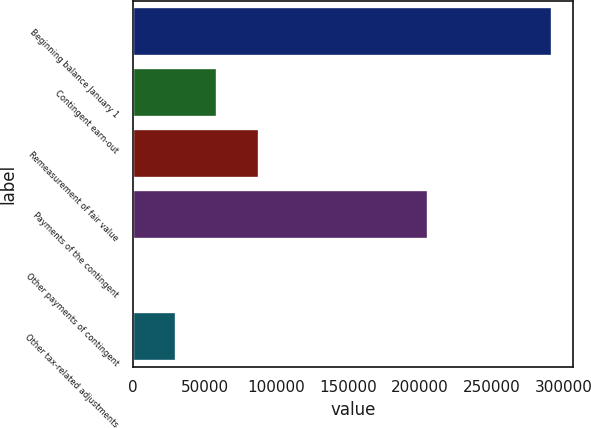Convert chart to OTSL. <chart><loc_0><loc_0><loc_500><loc_500><bar_chart><fcel>Beginning balance January 1<fcel>Contingent earn-out<fcel>Remeasurement of fair value<fcel>Payments of the contingent<fcel>Other payments of contingent<fcel>Other tax-related adjustments<nl><fcel>292042<fcel>58712.4<fcel>87878.6<fcel>205704<fcel>380<fcel>29546.2<nl></chart> 